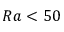Convert formula to latex. <formula><loc_0><loc_0><loc_500><loc_500>R a < 5 0</formula> 